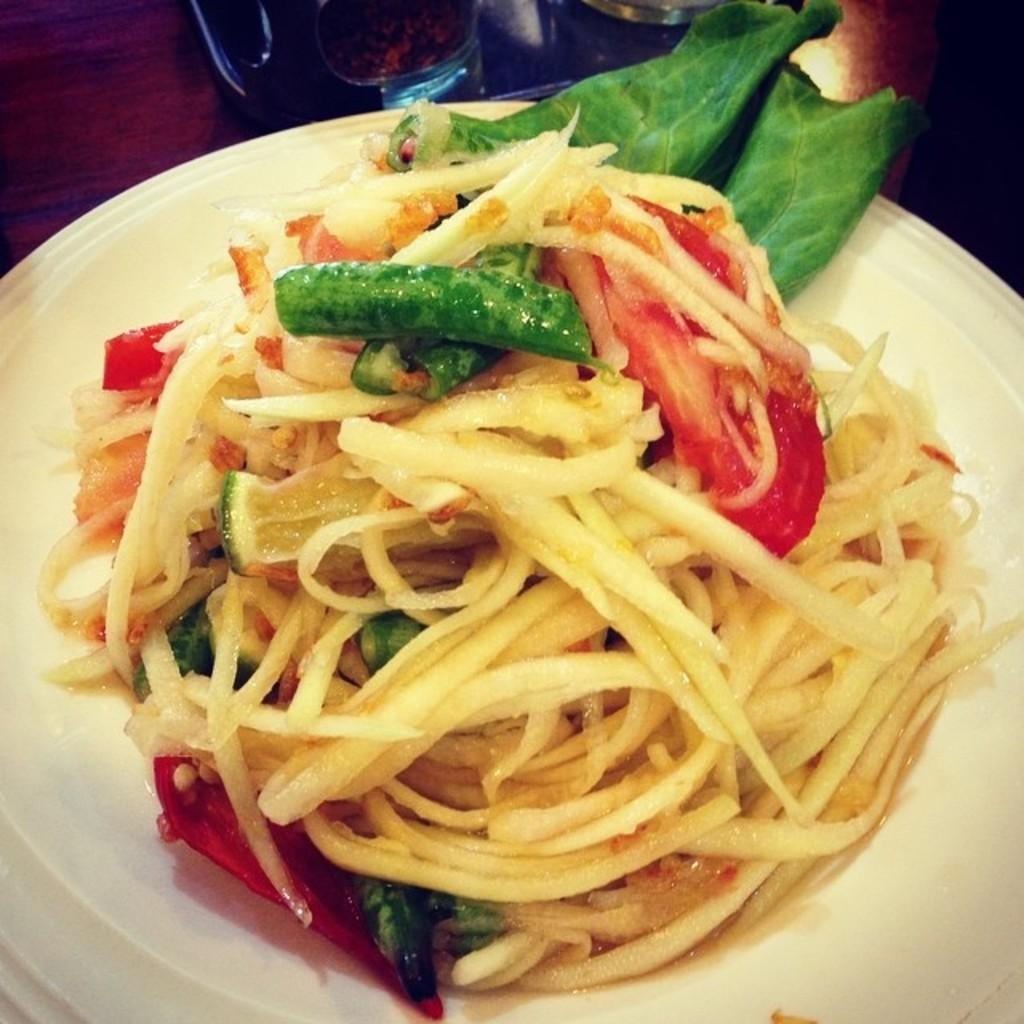What is on the plate that is visible in the image? There is food on a white plate in the image. What type of material is the object visible in the image made of? The object visible in the image is made of wood. Can you describe the unspecified items in the top part of the image? Unfortunately, the facts provided do not specify the nature of the additional items in the top part of the image. What is the reason for the cakes being placed on the wooden object in the image? There is no mention of cakes in the provided facts, and therefore no such reason can be determined. How many balls are visible in the image? There is no mention of balls in the provided facts, and therefore no such count can be determined. 